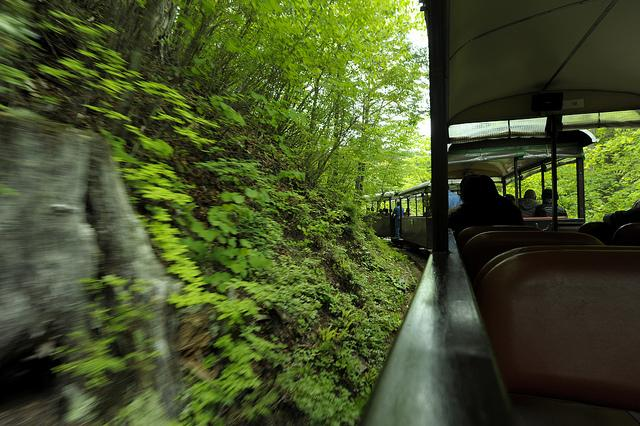If you stuck your hand out the side what would happen? Please explain your reasoning. touch plants. There are no cats, people, or sources of electricity outside the train. there are green items. 